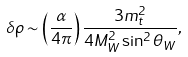<formula> <loc_0><loc_0><loc_500><loc_500>\delta \rho \sim \left ( \frac { \alpha } { 4 \pi } \right ) \frac { 3 m _ { t } ^ { 2 } } { 4 M _ { W } ^ { 2 } \sin ^ { 2 } \theta _ { W } } ,</formula> 